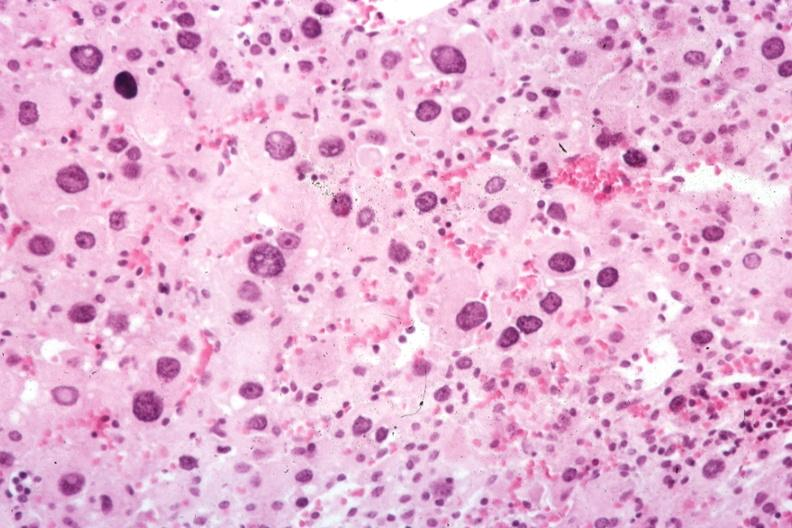what is present?
Answer the question using a single word or phrase. Endocrine 